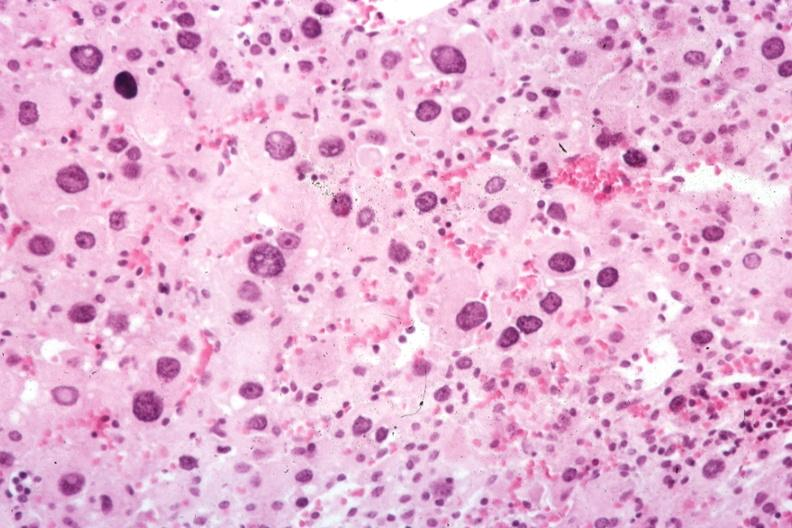what is present?
Answer the question using a single word or phrase. Endocrine 